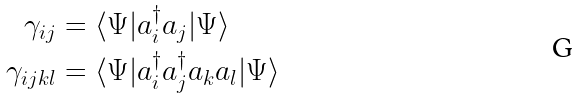<formula> <loc_0><loc_0><loc_500><loc_500>\gamma _ { i j } & = \langle \Psi | a ^ { \dag } _ { i } a _ { j } | \Psi \rangle \\ \gamma _ { i j k l } & = \langle \Psi | a ^ { \dag } _ { i } a ^ { \dag } _ { j } a _ { k } a _ { l } | \Psi \rangle</formula> 